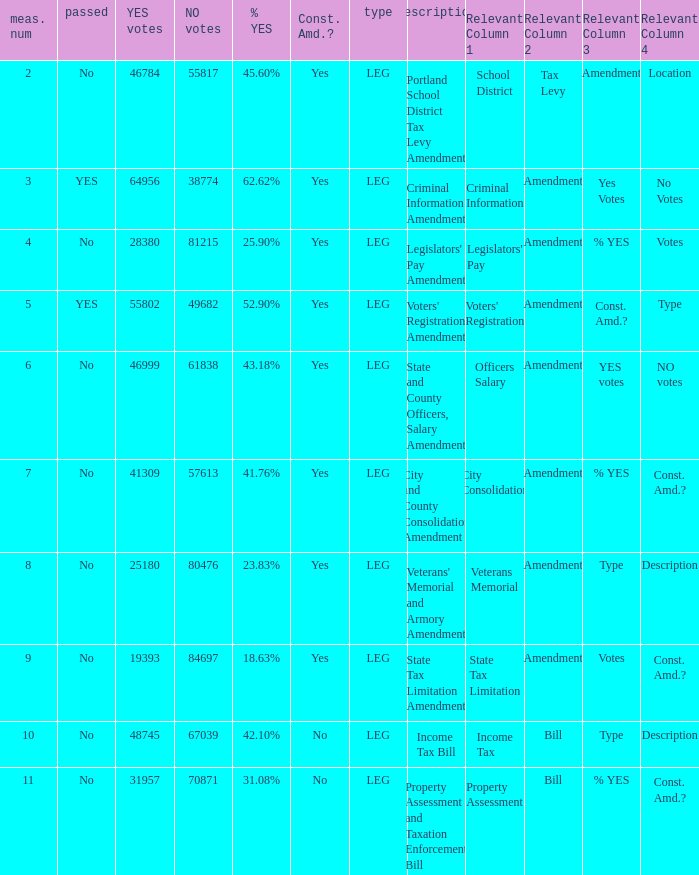Can you parse all the data within this table? {'header': ['meas. num', 'passed', 'YES votes', 'NO votes', '% YES', 'Const. Amd.?', 'type', 'description', 'Relevant Column 1', 'Relevant Column 2', 'Relevant Column 3', 'Relevant Column 4'], 'rows': [['2', 'No', '46784', '55817', '45.60%', 'Yes', 'LEG', 'Portland School District Tax Levy Amendment', 'School District', 'Tax Levy', 'Amendment', 'Location'], ['3', 'YES', '64956', '38774', '62.62%', 'Yes', 'LEG', 'Criminal Information Amendment', 'Criminal Information', 'Amendment', 'Yes Votes', 'No Votes'], ['4', 'No', '28380', '81215', '25.90%', 'Yes', 'LEG', "Legislators' Pay Amendment", "Legislators' Pay", 'Amendment', '% YES', 'Votes'], ['5', 'YES', '55802', '49682', '52.90%', 'Yes', 'LEG', "Voters' Registration Amendment", "Voters' Registration", 'Amendment', 'Const. Amd.?', 'Type'], ['6', 'No', '46999', '61838', '43.18%', 'Yes', 'LEG', 'State and County Officers, Salary Amendment', 'Officers Salary', 'Amendment', 'YES votes', 'NO votes'], ['7', 'No', '41309', '57613', '41.76%', 'Yes', 'LEG', 'City and County Consolidation Amendment', 'City Consolidation', 'Amendment', '% YES', 'Const. Amd.?'], ['8', 'No', '25180', '80476', '23.83%', 'Yes', 'LEG', "Veterans' Memorial and Armory Amendment", 'Veterans Memorial', 'Amendment', 'Type', 'Description'], ['9', 'No', '19393', '84697', '18.63%', 'Yes', 'LEG', 'State Tax Limitation Amendment', 'State Tax Limitation', 'Amendment', 'Votes', 'Const. Amd.?'], ['10', 'No', '48745', '67039', '42.10%', 'No', 'LEG', 'Income Tax Bill', 'Income Tax', 'Bill', 'Type', 'Description'], ['11', 'No', '31957', '70871', '31.08%', 'No', 'LEG', 'Property Assessment and Taxation Enforcement Bill', 'Property Assessment', 'Bill', '% YES', 'Const. Amd.?']]} How many yes votes made up 43.18% yes? 46999.0. 